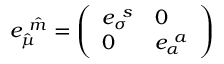<formula> <loc_0><loc_0><loc_500><loc_500>{ e _ { \hat { \mu } } ^ { \ \hat { m } } = \left ( \begin{array} { l l } { { e _ { \sigma } ^ { \ s } } } & { 0 } \\ { 0 } & { { e _ { \alpha } ^ { \ a } } } \end{array} \right ) }</formula> 